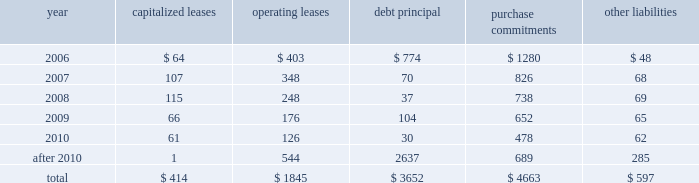Dividends is subject to the discretion of the board of directors and will depend on various factors , including our net income , financial condition , cash requirements , future prospects , and other relevant factors .
We expect to continue the practice of paying regular cash dividends .
During 2005 , we repaid $ 589 million in debt , primarily consisting of paydowns of commercial paper , scheduled principal payments on capital lease obligations , and repayments of debt that was previously assumed with the acquisitions of lynx express ltd .
And overnite corp .
Issuances of debt were $ 128 million in 2005 , and consisted primarily of loans related to our investment in certain equity-method real estate partnerships .
We consider the overall fixed and floating interest rate mix of our portfolio and the related overall cost of borrowing when planning for future issuances and non-scheduled repayments of debt .
Sources of credit we maintain two commercial paper programs under which we are authorized to borrow up to $ 7.0 billion in the united states .
We had $ 739 million outstanding under these programs as of december 31 , 2005 , with an average interest rate of 4.01% ( 4.01 % ) .
The entire balance outstanding has been classified as a current liability in our balance sheet .
We also maintain a european commercial paper program under which we are authorized to borrow up to 20ac1.0 billion in a variety of currencies .
There were no amounts outstanding under this program as of december 31 , 2005 .
We maintain two credit agreements with a consortium of banks .
These agreements provide revolving credit facilities of $ 1.0 billion each , with one expiring on april 20 , 2006 and the other on april 21 , 2010 .
Interest on any amounts we borrow under these facilities would be charged at 90-day libor plus 15 basis points .
There were no borrowings under either of these agreements as of december 31 , 2005 .
In august 2003 , we filed a $ 2.0 billion shelf registration statement under which we may issue debt securities in the united states .
There was approximately $ 126 million issued under this shelf registration statement at december 31 , 2005 , all of which consists of issuances under our ups notes program .
Our existing debt instruments and credit facilities do not have cross-default or ratings triggers , however these debt instruments and credit facilities do subject us to certain financial covenants .
These covenants generally require us to maintain a $ 3.0 billion minimum net worth and limit the amount of secured indebtedness available to the company .
These covenants are not considered material to the overall financial condition of the company , and all covenant tests were satisfied as of december 31 , 2005 .
Commitments we have contractual obligations and commitments in the form of operating leases , capital leases , debt obligations , purchase commitments , and certain other liabilities .
We intend to satisfy these obligations through the use of cash flow from operations .
The table summarizes our contractual obligations and commitments as of december 31 , 2005 ( in millions ) : capitalized leases operating leases principal purchase commitments liabilities .

What percentage of total contractual obligations and commitments as of december 31 , 2005 , are total debt principal? 
Computations: divide(3652, table_sum(total, none))
Answer: 0.32692. Dividends is subject to the discretion of the board of directors and will depend on various factors , including our net income , financial condition , cash requirements , future prospects , and other relevant factors .
We expect to continue the practice of paying regular cash dividends .
During 2005 , we repaid $ 589 million in debt , primarily consisting of paydowns of commercial paper , scheduled principal payments on capital lease obligations , and repayments of debt that was previously assumed with the acquisitions of lynx express ltd .
And overnite corp .
Issuances of debt were $ 128 million in 2005 , and consisted primarily of loans related to our investment in certain equity-method real estate partnerships .
We consider the overall fixed and floating interest rate mix of our portfolio and the related overall cost of borrowing when planning for future issuances and non-scheduled repayments of debt .
Sources of credit we maintain two commercial paper programs under which we are authorized to borrow up to $ 7.0 billion in the united states .
We had $ 739 million outstanding under these programs as of december 31 , 2005 , with an average interest rate of 4.01% ( 4.01 % ) .
The entire balance outstanding has been classified as a current liability in our balance sheet .
We also maintain a european commercial paper program under which we are authorized to borrow up to 20ac1.0 billion in a variety of currencies .
There were no amounts outstanding under this program as of december 31 , 2005 .
We maintain two credit agreements with a consortium of banks .
These agreements provide revolving credit facilities of $ 1.0 billion each , with one expiring on april 20 , 2006 and the other on april 21 , 2010 .
Interest on any amounts we borrow under these facilities would be charged at 90-day libor plus 15 basis points .
There were no borrowings under either of these agreements as of december 31 , 2005 .
In august 2003 , we filed a $ 2.0 billion shelf registration statement under which we may issue debt securities in the united states .
There was approximately $ 126 million issued under this shelf registration statement at december 31 , 2005 , all of which consists of issuances under our ups notes program .
Our existing debt instruments and credit facilities do not have cross-default or ratings triggers , however these debt instruments and credit facilities do subject us to certain financial covenants .
These covenants generally require us to maintain a $ 3.0 billion minimum net worth and limit the amount of secured indebtedness available to the company .
These covenants are not considered material to the overall financial condition of the company , and all covenant tests were satisfied as of december 31 , 2005 .
Commitments we have contractual obligations and commitments in the form of operating leases , capital leases , debt obligations , purchase commitments , and certain other liabilities .
We intend to satisfy these obligations through the use of cash flow from operations .
The table summarizes our contractual obligations and commitments as of december 31 , 2005 ( in millions ) : capitalized leases operating leases principal purchase commitments liabilities .

What is the total of contractual obligations and commitments as of december 31 , 2005 , in millions? 
Computations: table_sum(total, none)
Answer: 11171.0. 